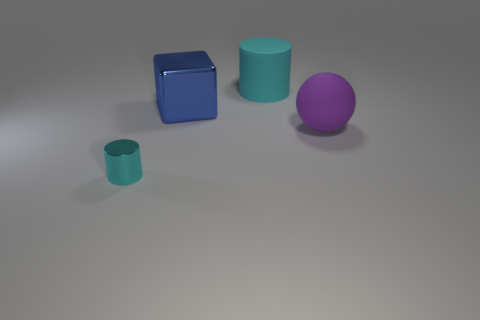Add 2 metal objects. How many objects exist? 6 Subtract all blocks. How many objects are left? 3 Subtract 0 purple cylinders. How many objects are left? 4 Subtract all purple rubber blocks. Subtract all cyan objects. How many objects are left? 2 Add 3 small metal cylinders. How many small metal cylinders are left? 4 Add 4 cylinders. How many cylinders exist? 6 